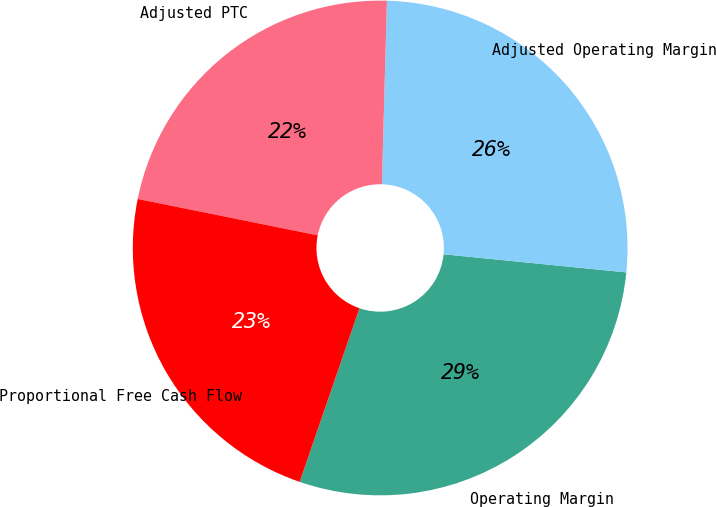Convert chart. <chart><loc_0><loc_0><loc_500><loc_500><pie_chart><fcel>Operating Margin<fcel>Adjusted Operating Margin<fcel>Adjusted PTC<fcel>Proportional Free Cash Flow<nl><fcel>28.7%<fcel>26.14%<fcel>22.26%<fcel>22.9%<nl></chart> 